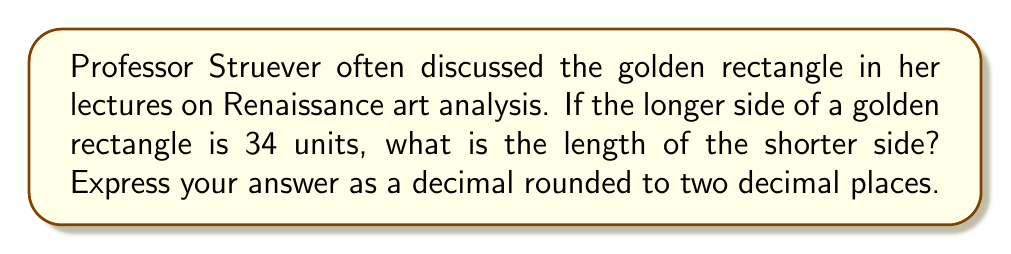Solve this math problem. Let's approach this step-by-step:

1) In a golden rectangle, the ratio of the longer side to the shorter side is equal to the golden ratio, φ (phi). This ratio is approximately 1.618033988749895...

2) We can express this relationship mathematically as:
   
   $$\frac{\text{longer side}}{\text{shorter side}} = φ$$

3) We're given that the longer side is 34 units. Let's call the shorter side $x$. We can now write:

   $$\frac{34}{x} = φ$$

4) To solve for $x$, we multiply both sides by $x$:

   $$34 = φx$$

5) Now divide both sides by φ:

   $$\frac{34}{φ} = x$$

6) We know that φ ≈ 1.618033988749895...

7) So, we can calculate:

   $$x = \frac{34}{1.618033988749895...} ≈ 21.01226...$$

8) Rounding to two decimal places, we get 21.01.

This demonstrates how the golden ratio governs the proportions of the golden rectangle, a concept frequently used in Renaissance art and architecture.
Answer: $21.01$ units 